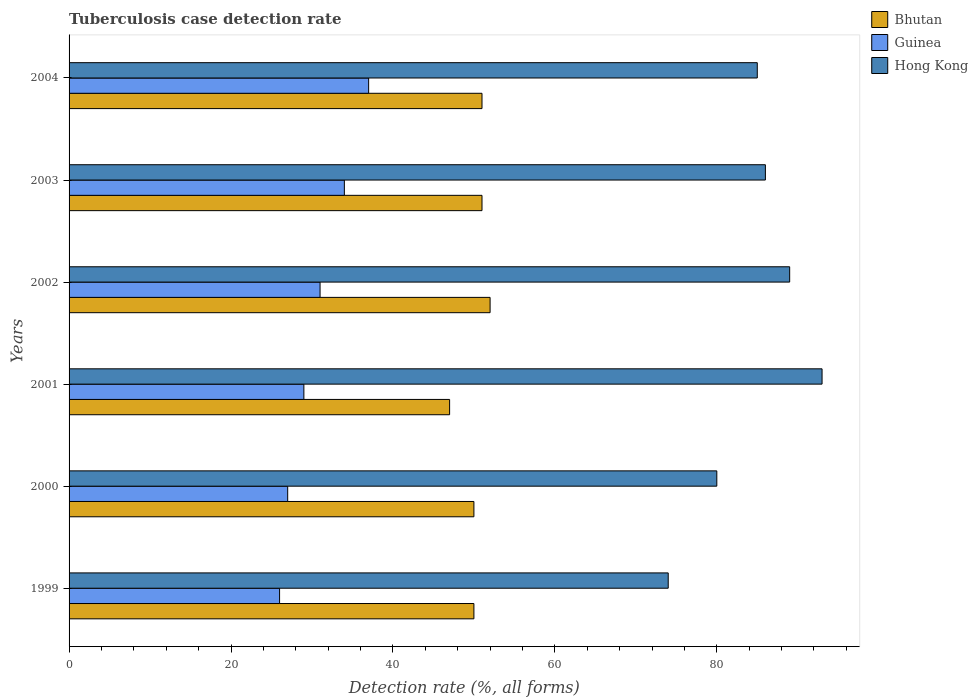How many different coloured bars are there?
Give a very brief answer. 3. How many groups of bars are there?
Ensure brevity in your answer.  6. In how many cases, is the number of bars for a given year not equal to the number of legend labels?
Offer a very short reply. 0. What is the tuberculosis case detection rate in in Hong Kong in 2003?
Provide a succinct answer. 86. Across all years, what is the maximum tuberculosis case detection rate in in Guinea?
Give a very brief answer. 37. What is the total tuberculosis case detection rate in in Hong Kong in the graph?
Your response must be concise. 507. What is the difference between the tuberculosis case detection rate in in Guinea in 2001 and the tuberculosis case detection rate in in Hong Kong in 2003?
Provide a short and direct response. -57. What is the average tuberculosis case detection rate in in Hong Kong per year?
Give a very brief answer. 84.5. In the year 1999, what is the difference between the tuberculosis case detection rate in in Guinea and tuberculosis case detection rate in in Hong Kong?
Your answer should be compact. -48. What is the ratio of the tuberculosis case detection rate in in Bhutan in 2002 to that in 2003?
Offer a terse response. 1.02. What is the difference between the highest and the second highest tuberculosis case detection rate in in Guinea?
Ensure brevity in your answer.  3. What is the difference between the highest and the lowest tuberculosis case detection rate in in Guinea?
Ensure brevity in your answer.  11. In how many years, is the tuberculosis case detection rate in in Hong Kong greater than the average tuberculosis case detection rate in in Hong Kong taken over all years?
Your response must be concise. 4. What does the 1st bar from the top in 2000 represents?
Give a very brief answer. Hong Kong. What does the 3rd bar from the bottom in 2001 represents?
Ensure brevity in your answer.  Hong Kong. Is it the case that in every year, the sum of the tuberculosis case detection rate in in Bhutan and tuberculosis case detection rate in in Hong Kong is greater than the tuberculosis case detection rate in in Guinea?
Ensure brevity in your answer.  Yes. Are all the bars in the graph horizontal?
Your response must be concise. Yes. How many years are there in the graph?
Give a very brief answer. 6. What is the difference between two consecutive major ticks on the X-axis?
Ensure brevity in your answer.  20. Does the graph contain grids?
Your answer should be very brief. No. Where does the legend appear in the graph?
Offer a terse response. Top right. How many legend labels are there?
Keep it short and to the point. 3. What is the title of the graph?
Ensure brevity in your answer.  Tuberculosis case detection rate. What is the label or title of the X-axis?
Provide a succinct answer. Detection rate (%, all forms). What is the Detection rate (%, all forms) of Guinea in 1999?
Keep it short and to the point. 26. What is the Detection rate (%, all forms) in Hong Kong in 2001?
Give a very brief answer. 93. What is the Detection rate (%, all forms) of Bhutan in 2002?
Give a very brief answer. 52. What is the Detection rate (%, all forms) of Guinea in 2002?
Offer a terse response. 31. What is the Detection rate (%, all forms) of Hong Kong in 2002?
Provide a short and direct response. 89. What is the Detection rate (%, all forms) in Hong Kong in 2003?
Give a very brief answer. 86. Across all years, what is the maximum Detection rate (%, all forms) of Bhutan?
Your answer should be very brief. 52. Across all years, what is the maximum Detection rate (%, all forms) of Guinea?
Your response must be concise. 37. Across all years, what is the maximum Detection rate (%, all forms) of Hong Kong?
Give a very brief answer. 93. Across all years, what is the minimum Detection rate (%, all forms) in Guinea?
Provide a succinct answer. 26. Across all years, what is the minimum Detection rate (%, all forms) in Hong Kong?
Your response must be concise. 74. What is the total Detection rate (%, all forms) in Bhutan in the graph?
Your response must be concise. 301. What is the total Detection rate (%, all forms) of Guinea in the graph?
Provide a succinct answer. 184. What is the total Detection rate (%, all forms) in Hong Kong in the graph?
Provide a succinct answer. 507. What is the difference between the Detection rate (%, all forms) of Bhutan in 1999 and that in 2000?
Your answer should be very brief. 0. What is the difference between the Detection rate (%, all forms) in Bhutan in 1999 and that in 2001?
Keep it short and to the point. 3. What is the difference between the Detection rate (%, all forms) in Bhutan in 1999 and that in 2002?
Your answer should be compact. -2. What is the difference between the Detection rate (%, all forms) in Hong Kong in 1999 and that in 2002?
Keep it short and to the point. -15. What is the difference between the Detection rate (%, all forms) in Hong Kong in 1999 and that in 2003?
Ensure brevity in your answer.  -12. What is the difference between the Detection rate (%, all forms) in Bhutan in 1999 and that in 2004?
Ensure brevity in your answer.  -1. What is the difference between the Detection rate (%, all forms) of Hong Kong in 1999 and that in 2004?
Ensure brevity in your answer.  -11. What is the difference between the Detection rate (%, all forms) of Bhutan in 2000 and that in 2001?
Ensure brevity in your answer.  3. What is the difference between the Detection rate (%, all forms) of Guinea in 2000 and that in 2001?
Make the answer very short. -2. What is the difference between the Detection rate (%, all forms) of Hong Kong in 2000 and that in 2001?
Provide a succinct answer. -13. What is the difference between the Detection rate (%, all forms) in Bhutan in 2000 and that in 2002?
Make the answer very short. -2. What is the difference between the Detection rate (%, all forms) in Guinea in 2000 and that in 2002?
Keep it short and to the point. -4. What is the difference between the Detection rate (%, all forms) in Hong Kong in 2000 and that in 2002?
Offer a very short reply. -9. What is the difference between the Detection rate (%, all forms) in Bhutan in 2000 and that in 2003?
Offer a terse response. -1. What is the difference between the Detection rate (%, all forms) in Hong Kong in 2000 and that in 2003?
Offer a very short reply. -6. What is the difference between the Detection rate (%, all forms) in Bhutan in 2000 and that in 2004?
Keep it short and to the point. -1. What is the difference between the Detection rate (%, all forms) in Hong Kong in 2000 and that in 2004?
Your response must be concise. -5. What is the difference between the Detection rate (%, all forms) in Bhutan in 2001 and that in 2002?
Offer a terse response. -5. What is the difference between the Detection rate (%, all forms) of Guinea in 2001 and that in 2002?
Your answer should be very brief. -2. What is the difference between the Detection rate (%, all forms) of Hong Kong in 2001 and that in 2002?
Offer a terse response. 4. What is the difference between the Detection rate (%, all forms) in Bhutan in 2001 and that in 2003?
Ensure brevity in your answer.  -4. What is the difference between the Detection rate (%, all forms) in Hong Kong in 2001 and that in 2004?
Ensure brevity in your answer.  8. What is the difference between the Detection rate (%, all forms) in Guinea in 2002 and that in 2003?
Provide a succinct answer. -3. What is the difference between the Detection rate (%, all forms) in Hong Kong in 2002 and that in 2003?
Offer a terse response. 3. What is the difference between the Detection rate (%, all forms) of Bhutan in 2002 and that in 2004?
Ensure brevity in your answer.  1. What is the difference between the Detection rate (%, all forms) in Hong Kong in 2002 and that in 2004?
Make the answer very short. 4. What is the difference between the Detection rate (%, all forms) of Guinea in 2003 and that in 2004?
Keep it short and to the point. -3. What is the difference between the Detection rate (%, all forms) in Hong Kong in 2003 and that in 2004?
Your answer should be very brief. 1. What is the difference between the Detection rate (%, all forms) in Bhutan in 1999 and the Detection rate (%, all forms) in Guinea in 2000?
Your answer should be very brief. 23. What is the difference between the Detection rate (%, all forms) of Bhutan in 1999 and the Detection rate (%, all forms) of Hong Kong in 2000?
Ensure brevity in your answer.  -30. What is the difference between the Detection rate (%, all forms) in Guinea in 1999 and the Detection rate (%, all forms) in Hong Kong in 2000?
Provide a short and direct response. -54. What is the difference between the Detection rate (%, all forms) of Bhutan in 1999 and the Detection rate (%, all forms) of Guinea in 2001?
Make the answer very short. 21. What is the difference between the Detection rate (%, all forms) of Bhutan in 1999 and the Detection rate (%, all forms) of Hong Kong in 2001?
Offer a very short reply. -43. What is the difference between the Detection rate (%, all forms) in Guinea in 1999 and the Detection rate (%, all forms) in Hong Kong in 2001?
Make the answer very short. -67. What is the difference between the Detection rate (%, all forms) of Bhutan in 1999 and the Detection rate (%, all forms) of Guinea in 2002?
Offer a very short reply. 19. What is the difference between the Detection rate (%, all forms) in Bhutan in 1999 and the Detection rate (%, all forms) in Hong Kong in 2002?
Your answer should be very brief. -39. What is the difference between the Detection rate (%, all forms) of Guinea in 1999 and the Detection rate (%, all forms) of Hong Kong in 2002?
Ensure brevity in your answer.  -63. What is the difference between the Detection rate (%, all forms) in Bhutan in 1999 and the Detection rate (%, all forms) in Hong Kong in 2003?
Offer a very short reply. -36. What is the difference between the Detection rate (%, all forms) of Guinea in 1999 and the Detection rate (%, all forms) of Hong Kong in 2003?
Your answer should be compact. -60. What is the difference between the Detection rate (%, all forms) of Bhutan in 1999 and the Detection rate (%, all forms) of Guinea in 2004?
Your answer should be compact. 13. What is the difference between the Detection rate (%, all forms) of Bhutan in 1999 and the Detection rate (%, all forms) of Hong Kong in 2004?
Provide a succinct answer. -35. What is the difference between the Detection rate (%, all forms) of Guinea in 1999 and the Detection rate (%, all forms) of Hong Kong in 2004?
Provide a succinct answer. -59. What is the difference between the Detection rate (%, all forms) of Bhutan in 2000 and the Detection rate (%, all forms) of Hong Kong in 2001?
Offer a terse response. -43. What is the difference between the Detection rate (%, all forms) in Guinea in 2000 and the Detection rate (%, all forms) in Hong Kong in 2001?
Your answer should be very brief. -66. What is the difference between the Detection rate (%, all forms) of Bhutan in 2000 and the Detection rate (%, all forms) of Hong Kong in 2002?
Make the answer very short. -39. What is the difference between the Detection rate (%, all forms) in Guinea in 2000 and the Detection rate (%, all forms) in Hong Kong in 2002?
Offer a terse response. -62. What is the difference between the Detection rate (%, all forms) in Bhutan in 2000 and the Detection rate (%, all forms) in Hong Kong in 2003?
Offer a very short reply. -36. What is the difference between the Detection rate (%, all forms) in Guinea in 2000 and the Detection rate (%, all forms) in Hong Kong in 2003?
Offer a terse response. -59. What is the difference between the Detection rate (%, all forms) in Bhutan in 2000 and the Detection rate (%, all forms) in Guinea in 2004?
Keep it short and to the point. 13. What is the difference between the Detection rate (%, all forms) in Bhutan in 2000 and the Detection rate (%, all forms) in Hong Kong in 2004?
Ensure brevity in your answer.  -35. What is the difference between the Detection rate (%, all forms) of Guinea in 2000 and the Detection rate (%, all forms) of Hong Kong in 2004?
Ensure brevity in your answer.  -58. What is the difference between the Detection rate (%, all forms) of Bhutan in 2001 and the Detection rate (%, all forms) of Guinea in 2002?
Keep it short and to the point. 16. What is the difference between the Detection rate (%, all forms) in Bhutan in 2001 and the Detection rate (%, all forms) in Hong Kong in 2002?
Give a very brief answer. -42. What is the difference between the Detection rate (%, all forms) in Guinea in 2001 and the Detection rate (%, all forms) in Hong Kong in 2002?
Provide a short and direct response. -60. What is the difference between the Detection rate (%, all forms) in Bhutan in 2001 and the Detection rate (%, all forms) in Guinea in 2003?
Make the answer very short. 13. What is the difference between the Detection rate (%, all forms) in Bhutan in 2001 and the Detection rate (%, all forms) in Hong Kong in 2003?
Keep it short and to the point. -39. What is the difference between the Detection rate (%, all forms) of Guinea in 2001 and the Detection rate (%, all forms) of Hong Kong in 2003?
Make the answer very short. -57. What is the difference between the Detection rate (%, all forms) of Bhutan in 2001 and the Detection rate (%, all forms) of Guinea in 2004?
Provide a succinct answer. 10. What is the difference between the Detection rate (%, all forms) of Bhutan in 2001 and the Detection rate (%, all forms) of Hong Kong in 2004?
Your response must be concise. -38. What is the difference between the Detection rate (%, all forms) in Guinea in 2001 and the Detection rate (%, all forms) in Hong Kong in 2004?
Keep it short and to the point. -56. What is the difference between the Detection rate (%, all forms) in Bhutan in 2002 and the Detection rate (%, all forms) in Guinea in 2003?
Make the answer very short. 18. What is the difference between the Detection rate (%, all forms) in Bhutan in 2002 and the Detection rate (%, all forms) in Hong Kong in 2003?
Give a very brief answer. -34. What is the difference between the Detection rate (%, all forms) in Guinea in 2002 and the Detection rate (%, all forms) in Hong Kong in 2003?
Offer a terse response. -55. What is the difference between the Detection rate (%, all forms) in Bhutan in 2002 and the Detection rate (%, all forms) in Guinea in 2004?
Your answer should be compact. 15. What is the difference between the Detection rate (%, all forms) of Bhutan in 2002 and the Detection rate (%, all forms) of Hong Kong in 2004?
Offer a very short reply. -33. What is the difference between the Detection rate (%, all forms) of Guinea in 2002 and the Detection rate (%, all forms) of Hong Kong in 2004?
Offer a terse response. -54. What is the difference between the Detection rate (%, all forms) of Bhutan in 2003 and the Detection rate (%, all forms) of Guinea in 2004?
Your answer should be very brief. 14. What is the difference between the Detection rate (%, all forms) in Bhutan in 2003 and the Detection rate (%, all forms) in Hong Kong in 2004?
Offer a very short reply. -34. What is the difference between the Detection rate (%, all forms) of Guinea in 2003 and the Detection rate (%, all forms) of Hong Kong in 2004?
Your response must be concise. -51. What is the average Detection rate (%, all forms) in Bhutan per year?
Ensure brevity in your answer.  50.17. What is the average Detection rate (%, all forms) of Guinea per year?
Offer a very short reply. 30.67. What is the average Detection rate (%, all forms) in Hong Kong per year?
Give a very brief answer. 84.5. In the year 1999, what is the difference between the Detection rate (%, all forms) of Guinea and Detection rate (%, all forms) of Hong Kong?
Offer a terse response. -48. In the year 2000, what is the difference between the Detection rate (%, all forms) of Bhutan and Detection rate (%, all forms) of Hong Kong?
Offer a terse response. -30. In the year 2000, what is the difference between the Detection rate (%, all forms) of Guinea and Detection rate (%, all forms) of Hong Kong?
Offer a terse response. -53. In the year 2001, what is the difference between the Detection rate (%, all forms) in Bhutan and Detection rate (%, all forms) in Hong Kong?
Make the answer very short. -46. In the year 2001, what is the difference between the Detection rate (%, all forms) in Guinea and Detection rate (%, all forms) in Hong Kong?
Ensure brevity in your answer.  -64. In the year 2002, what is the difference between the Detection rate (%, all forms) of Bhutan and Detection rate (%, all forms) of Guinea?
Give a very brief answer. 21. In the year 2002, what is the difference between the Detection rate (%, all forms) in Bhutan and Detection rate (%, all forms) in Hong Kong?
Your answer should be very brief. -37. In the year 2002, what is the difference between the Detection rate (%, all forms) of Guinea and Detection rate (%, all forms) of Hong Kong?
Offer a terse response. -58. In the year 2003, what is the difference between the Detection rate (%, all forms) in Bhutan and Detection rate (%, all forms) in Hong Kong?
Provide a short and direct response. -35. In the year 2003, what is the difference between the Detection rate (%, all forms) in Guinea and Detection rate (%, all forms) in Hong Kong?
Ensure brevity in your answer.  -52. In the year 2004, what is the difference between the Detection rate (%, all forms) of Bhutan and Detection rate (%, all forms) of Hong Kong?
Provide a short and direct response. -34. In the year 2004, what is the difference between the Detection rate (%, all forms) in Guinea and Detection rate (%, all forms) in Hong Kong?
Offer a very short reply. -48. What is the ratio of the Detection rate (%, all forms) of Bhutan in 1999 to that in 2000?
Your answer should be very brief. 1. What is the ratio of the Detection rate (%, all forms) in Hong Kong in 1999 to that in 2000?
Make the answer very short. 0.93. What is the ratio of the Detection rate (%, all forms) in Bhutan in 1999 to that in 2001?
Your answer should be very brief. 1.06. What is the ratio of the Detection rate (%, all forms) of Guinea in 1999 to that in 2001?
Offer a terse response. 0.9. What is the ratio of the Detection rate (%, all forms) of Hong Kong in 1999 to that in 2001?
Your answer should be very brief. 0.8. What is the ratio of the Detection rate (%, all forms) in Bhutan in 1999 to that in 2002?
Your response must be concise. 0.96. What is the ratio of the Detection rate (%, all forms) in Guinea in 1999 to that in 2002?
Offer a terse response. 0.84. What is the ratio of the Detection rate (%, all forms) in Hong Kong in 1999 to that in 2002?
Provide a succinct answer. 0.83. What is the ratio of the Detection rate (%, all forms) in Bhutan in 1999 to that in 2003?
Your answer should be very brief. 0.98. What is the ratio of the Detection rate (%, all forms) in Guinea in 1999 to that in 2003?
Offer a terse response. 0.76. What is the ratio of the Detection rate (%, all forms) in Hong Kong in 1999 to that in 2003?
Offer a very short reply. 0.86. What is the ratio of the Detection rate (%, all forms) of Bhutan in 1999 to that in 2004?
Your answer should be compact. 0.98. What is the ratio of the Detection rate (%, all forms) in Guinea in 1999 to that in 2004?
Your response must be concise. 0.7. What is the ratio of the Detection rate (%, all forms) in Hong Kong in 1999 to that in 2004?
Offer a terse response. 0.87. What is the ratio of the Detection rate (%, all forms) of Bhutan in 2000 to that in 2001?
Make the answer very short. 1.06. What is the ratio of the Detection rate (%, all forms) in Hong Kong in 2000 to that in 2001?
Your response must be concise. 0.86. What is the ratio of the Detection rate (%, all forms) in Bhutan in 2000 to that in 2002?
Your response must be concise. 0.96. What is the ratio of the Detection rate (%, all forms) of Guinea in 2000 to that in 2002?
Provide a short and direct response. 0.87. What is the ratio of the Detection rate (%, all forms) of Hong Kong in 2000 to that in 2002?
Your answer should be compact. 0.9. What is the ratio of the Detection rate (%, all forms) in Bhutan in 2000 to that in 2003?
Keep it short and to the point. 0.98. What is the ratio of the Detection rate (%, all forms) in Guinea in 2000 to that in 2003?
Your response must be concise. 0.79. What is the ratio of the Detection rate (%, all forms) of Hong Kong in 2000 to that in 2003?
Provide a short and direct response. 0.93. What is the ratio of the Detection rate (%, all forms) of Bhutan in 2000 to that in 2004?
Your answer should be very brief. 0.98. What is the ratio of the Detection rate (%, all forms) of Guinea in 2000 to that in 2004?
Make the answer very short. 0.73. What is the ratio of the Detection rate (%, all forms) of Hong Kong in 2000 to that in 2004?
Ensure brevity in your answer.  0.94. What is the ratio of the Detection rate (%, all forms) in Bhutan in 2001 to that in 2002?
Your answer should be very brief. 0.9. What is the ratio of the Detection rate (%, all forms) of Guinea in 2001 to that in 2002?
Provide a short and direct response. 0.94. What is the ratio of the Detection rate (%, all forms) in Hong Kong in 2001 to that in 2002?
Offer a very short reply. 1.04. What is the ratio of the Detection rate (%, all forms) of Bhutan in 2001 to that in 2003?
Provide a short and direct response. 0.92. What is the ratio of the Detection rate (%, all forms) in Guinea in 2001 to that in 2003?
Give a very brief answer. 0.85. What is the ratio of the Detection rate (%, all forms) of Hong Kong in 2001 to that in 2003?
Keep it short and to the point. 1.08. What is the ratio of the Detection rate (%, all forms) in Bhutan in 2001 to that in 2004?
Your answer should be compact. 0.92. What is the ratio of the Detection rate (%, all forms) of Guinea in 2001 to that in 2004?
Provide a succinct answer. 0.78. What is the ratio of the Detection rate (%, all forms) of Hong Kong in 2001 to that in 2004?
Your answer should be compact. 1.09. What is the ratio of the Detection rate (%, all forms) in Bhutan in 2002 to that in 2003?
Provide a short and direct response. 1.02. What is the ratio of the Detection rate (%, all forms) in Guinea in 2002 to that in 2003?
Give a very brief answer. 0.91. What is the ratio of the Detection rate (%, all forms) in Hong Kong in 2002 to that in 2003?
Keep it short and to the point. 1.03. What is the ratio of the Detection rate (%, all forms) of Bhutan in 2002 to that in 2004?
Make the answer very short. 1.02. What is the ratio of the Detection rate (%, all forms) of Guinea in 2002 to that in 2004?
Offer a terse response. 0.84. What is the ratio of the Detection rate (%, all forms) of Hong Kong in 2002 to that in 2004?
Provide a short and direct response. 1.05. What is the ratio of the Detection rate (%, all forms) in Bhutan in 2003 to that in 2004?
Make the answer very short. 1. What is the ratio of the Detection rate (%, all forms) in Guinea in 2003 to that in 2004?
Your answer should be compact. 0.92. What is the ratio of the Detection rate (%, all forms) of Hong Kong in 2003 to that in 2004?
Your answer should be very brief. 1.01. What is the difference between the highest and the second highest Detection rate (%, all forms) in Guinea?
Give a very brief answer. 3. What is the difference between the highest and the lowest Detection rate (%, all forms) of Bhutan?
Make the answer very short. 5. What is the difference between the highest and the lowest Detection rate (%, all forms) of Guinea?
Ensure brevity in your answer.  11. 